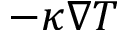<formula> <loc_0><loc_0><loc_500><loc_500>- \kappa \nabla T</formula> 